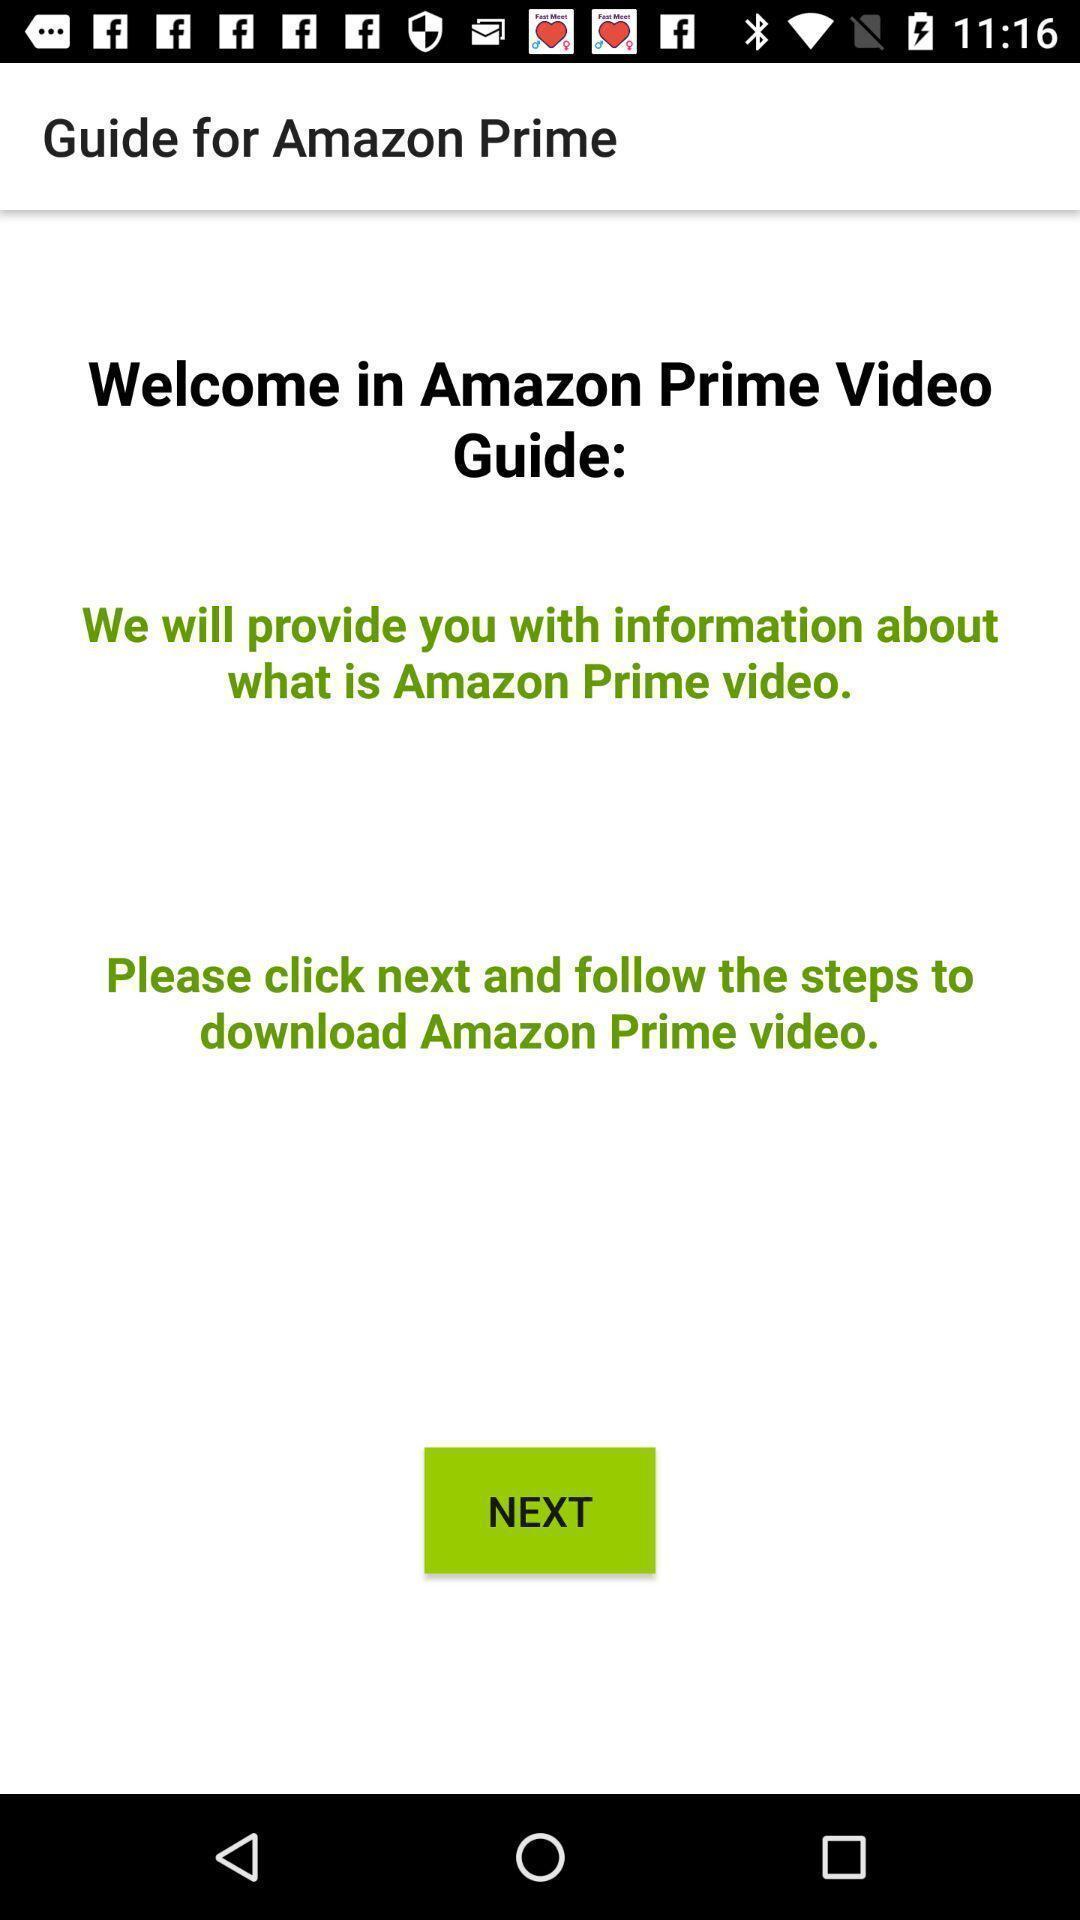Describe the key features of this screenshot. Welcome page of an entertainment app. 